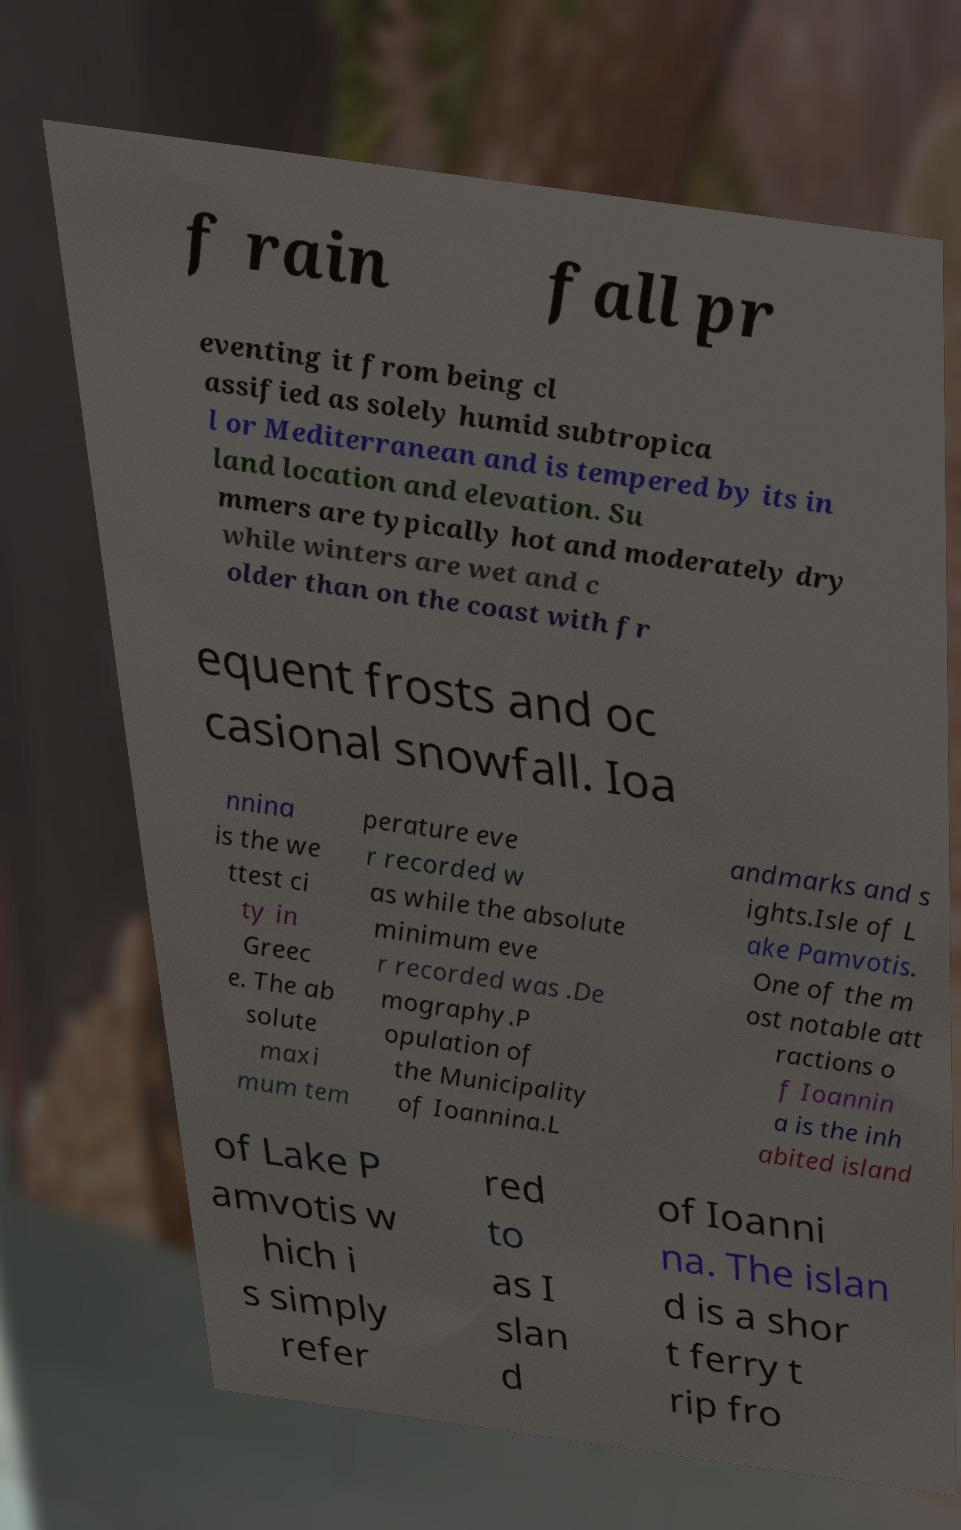Could you extract and type out the text from this image? f rain fall pr eventing it from being cl assified as solely humid subtropica l or Mediterranean and is tempered by its in land location and elevation. Su mmers are typically hot and moderately dry while winters are wet and c older than on the coast with fr equent frosts and oc casional snowfall. Ioa nnina is the we ttest ci ty in Greec e. The ab solute maxi mum tem perature eve r recorded w as while the absolute minimum eve r recorded was .De mography.P opulation of the Municipality of Ioannina.L andmarks and s ights.Isle of L ake Pamvotis. One of the m ost notable att ractions o f Ioannin a is the inh abited island of Lake P amvotis w hich i s simply refer red to as I slan d of Ioanni na. The islan d is a shor t ferry t rip fro 